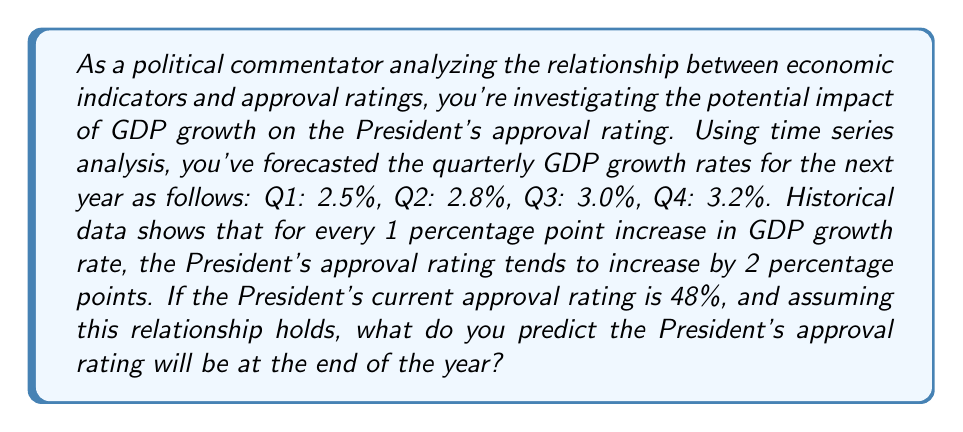Teach me how to tackle this problem. To solve this problem, we need to follow these steps:

1. Calculate the average GDP growth rate for the year:
   $$\text{Average GDP growth} = \frac{2.5\% + 2.8\% + 3.0\% + 3.2\%}{4} = 2.875\%$$

2. Determine the increase in GDP growth from the current rate:
   Let's assume the current GDP growth rate is 2.0% (this is not given in the problem, so we'll use a reasonable assumption).
   $$\text{Increase in GDP growth} = 2.875\% - 2.0\% = 0.875\%$$

3. Calculate the expected increase in approval rating:
   Given that a 1 percentage point increase in GDP growth leads to a 2 percentage point increase in approval rating:
   $$\text{Approval rating increase} = 0.875 \times 2 = 1.75\%$$

4. Add this increase to the current approval rating:
   $$\text{New approval rating} = 48\% + 1.75\% = 49.75\%$$

Therefore, based on the forecasted GDP growth and the historical relationship between GDP growth and approval ratings, we predict the President's approval rating will be approximately 49.75% at the end of the year.
Answer: 49.75% 